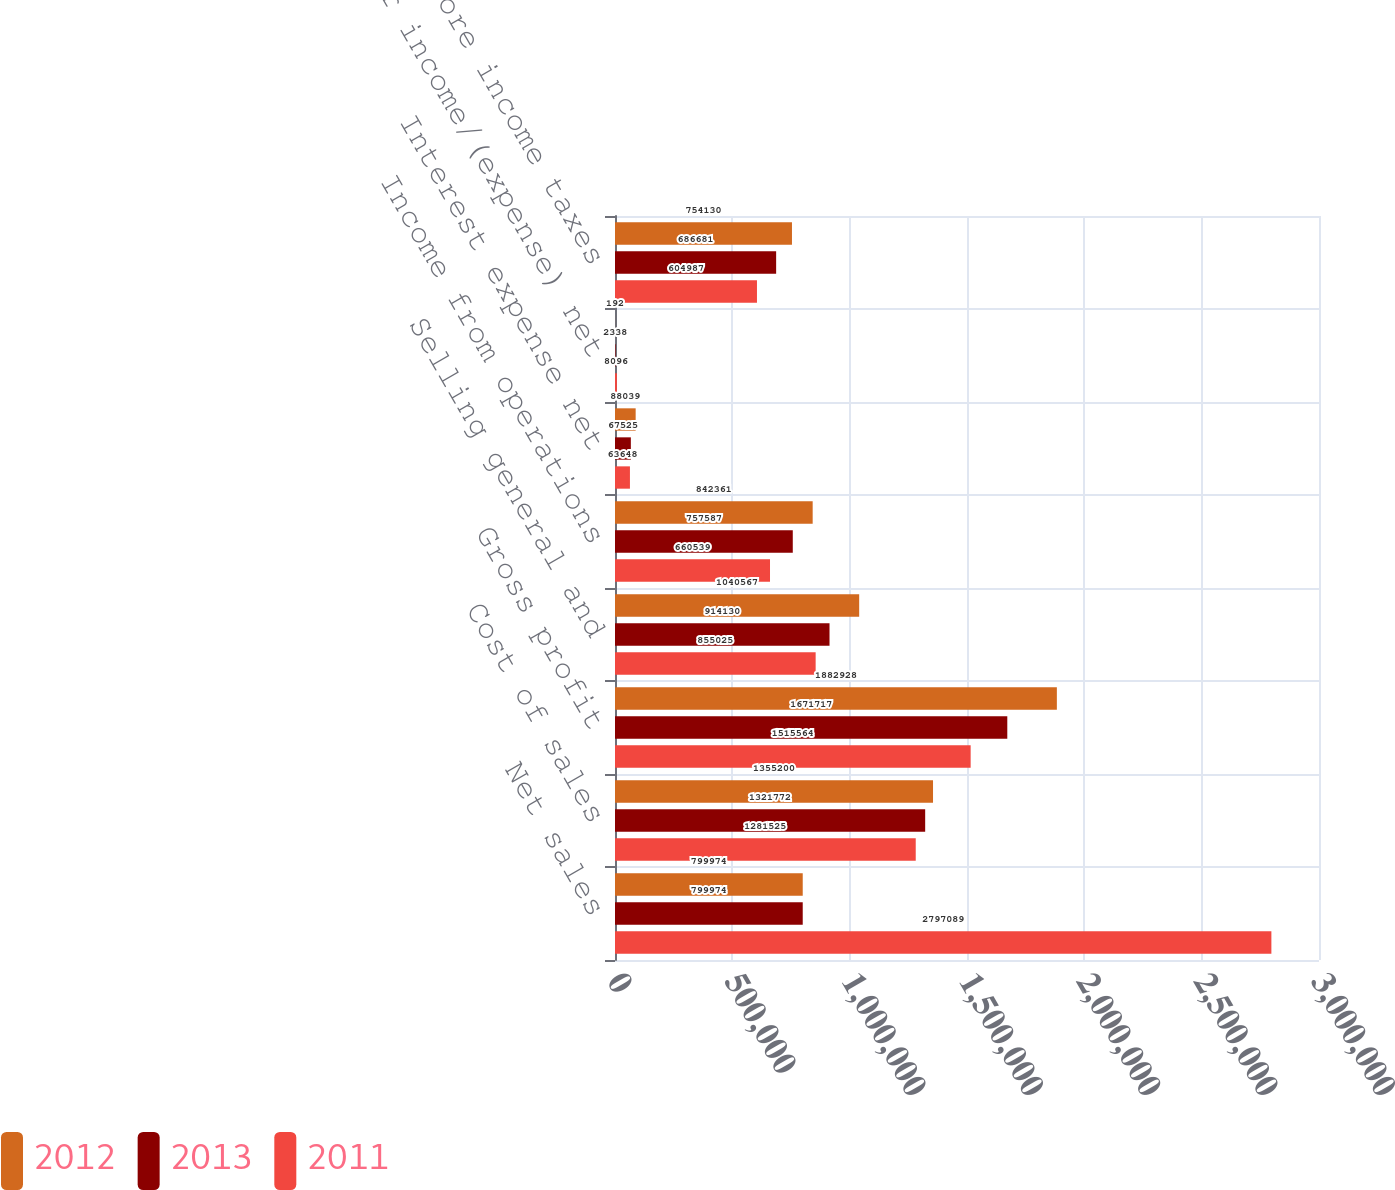<chart> <loc_0><loc_0><loc_500><loc_500><stacked_bar_chart><ecel><fcel>Net sales<fcel>Cost of sales<fcel>Gross profit<fcel>Selling general and<fcel>Income from operations<fcel>Interest expense net<fcel>Other income/(expense) net<fcel>Earnings before income taxes<nl><fcel>2012<fcel>799974<fcel>1.3552e+06<fcel>1.88293e+06<fcel>1.04057e+06<fcel>842361<fcel>88039<fcel>192<fcel>754130<nl><fcel>2013<fcel>799974<fcel>1.32177e+06<fcel>1.67172e+06<fcel>914130<fcel>757587<fcel>67525<fcel>2338<fcel>686681<nl><fcel>2011<fcel>2.79709e+06<fcel>1.28152e+06<fcel>1.51556e+06<fcel>855025<fcel>660539<fcel>63648<fcel>8096<fcel>604987<nl></chart> 